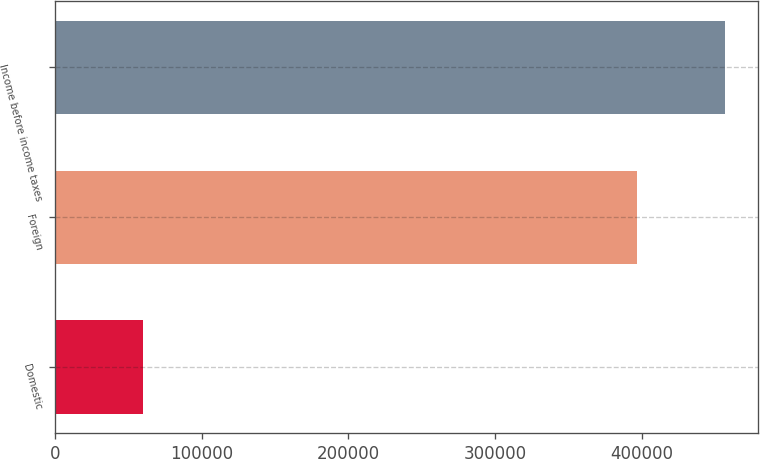Convert chart. <chart><loc_0><loc_0><loc_500><loc_500><bar_chart><fcel>Domestic<fcel>Foreign<fcel>Income before income taxes<nl><fcel>59966<fcel>396636<fcel>456602<nl></chart> 